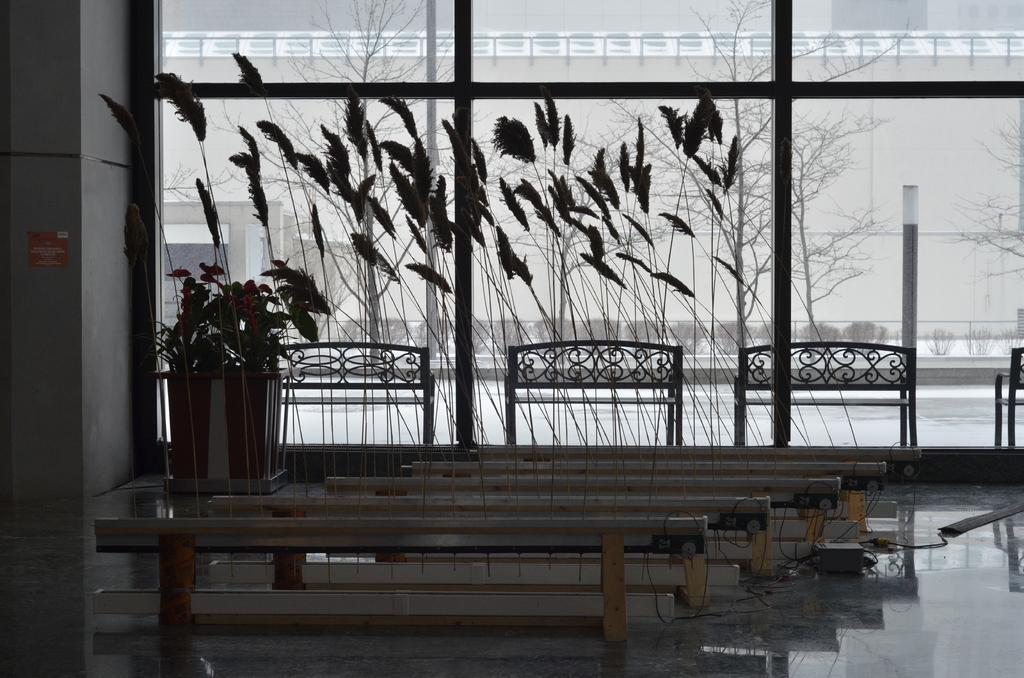Please provide a concise description of this image. There are few feathers and a pot. 